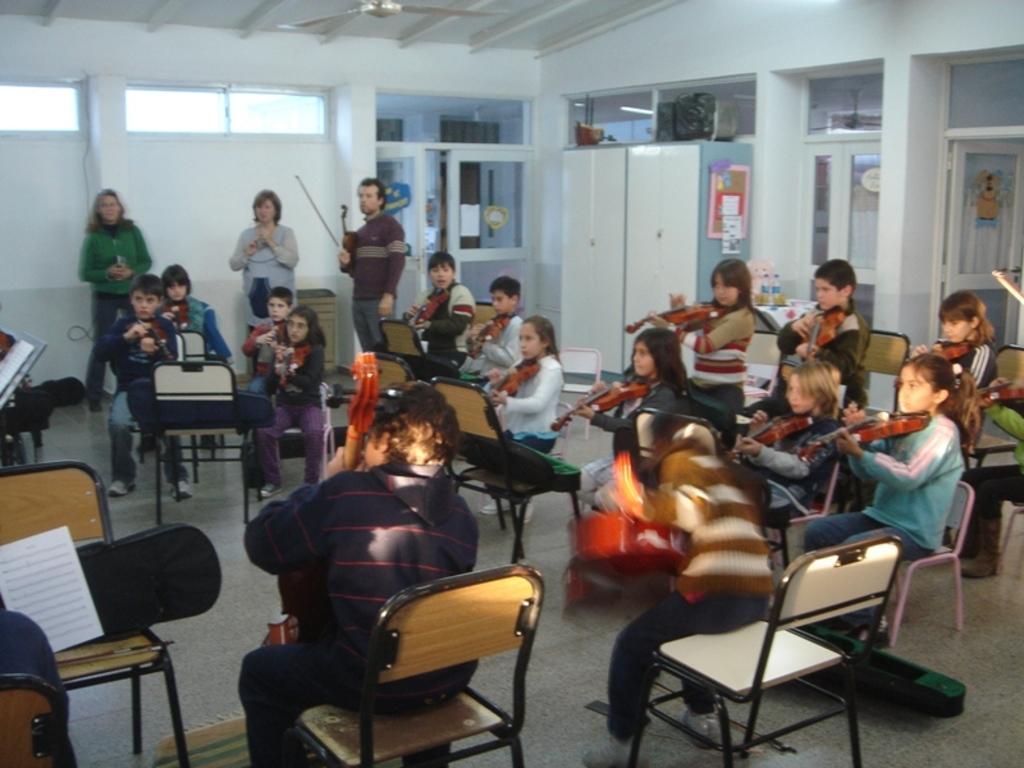Could you give a brief overview of what you see in this image? In this image i can see a group of children sitting and playing guitar at the back ground i can see two women standing and a man standing, a wall, a window and a door. 